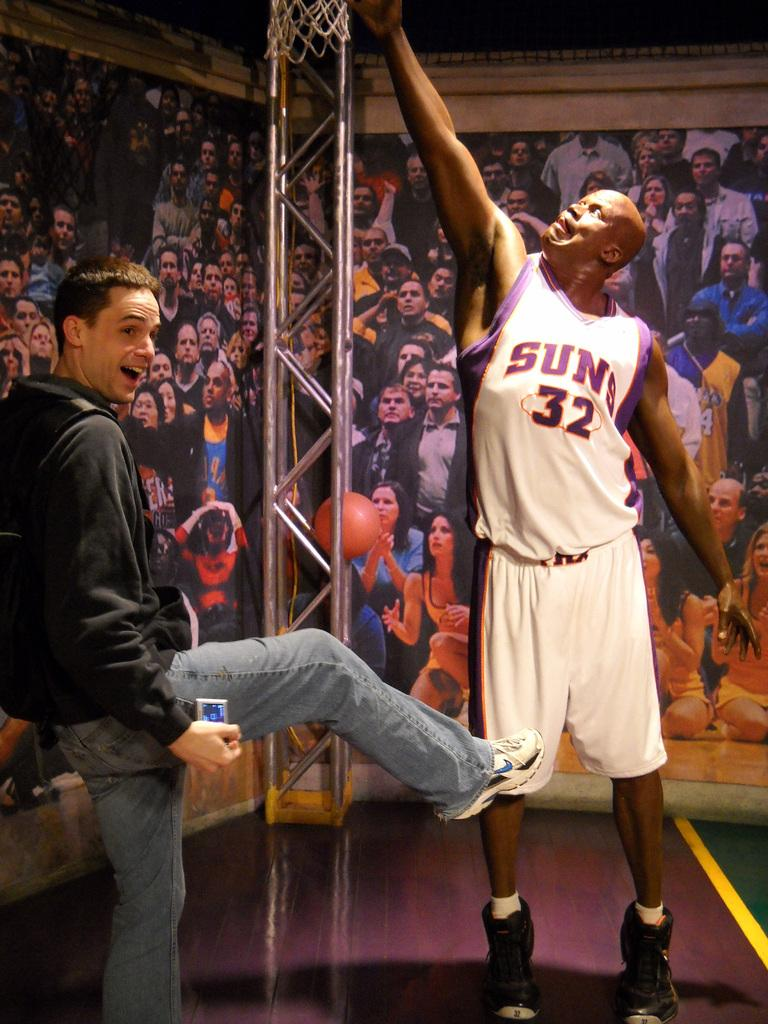<image>
Describe the image concisely. A man poses by a statue of player 32 of the Suns reaching for the net. 